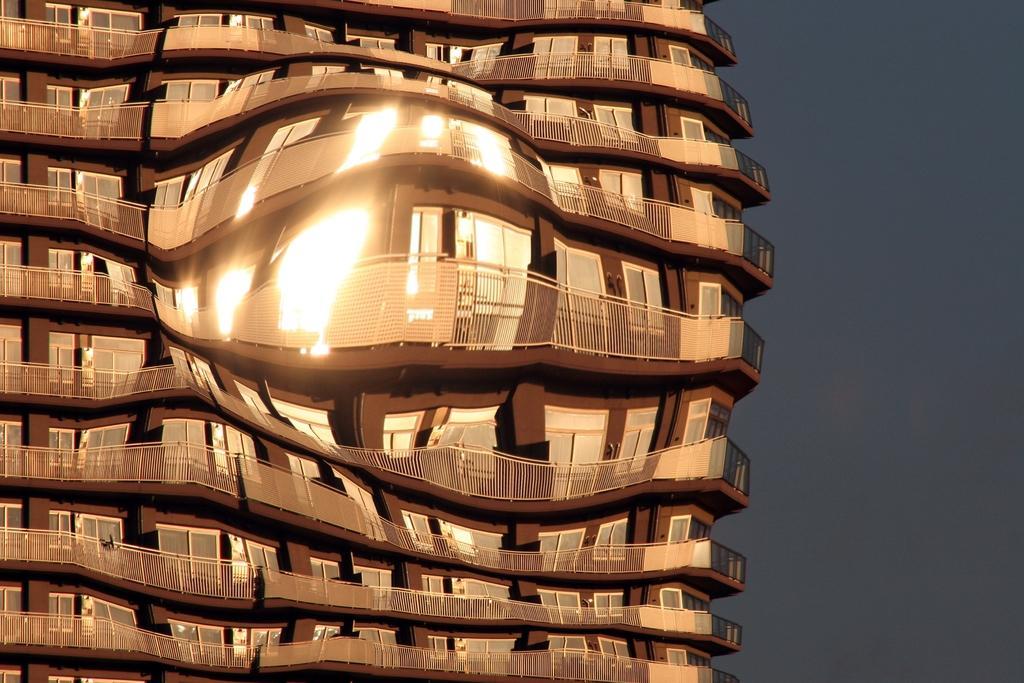Could you give a brief overview of what you see in this image? In this image I can see the edited image in which I can see a building which is brown and cream in color. In the background I can see the sky. 